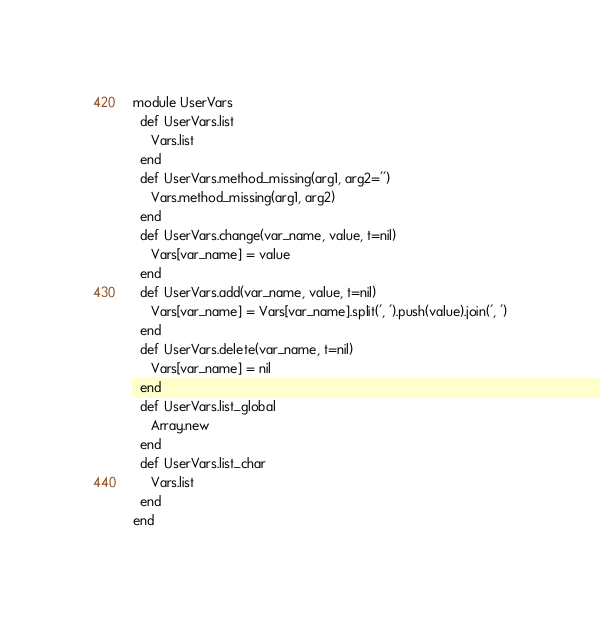<code> <loc_0><loc_0><loc_500><loc_500><_Ruby_>module UserVars
  def UserVars.list
     Vars.list
  end
  def UserVars.method_missing(arg1, arg2='')
     Vars.method_missing(arg1, arg2)
  end
  def UserVars.change(var_name, value, t=nil)
     Vars[var_name] = value
  end
  def UserVars.add(var_name, value, t=nil)
     Vars[var_name] = Vars[var_name].split(', ').push(value).join(', ')
  end
  def UserVars.delete(var_name, t=nil)
     Vars[var_name] = nil
  end
  def UserVars.list_global
     Array.new
  end
  def UserVars.list_char
     Vars.list
  end
end
</code> 